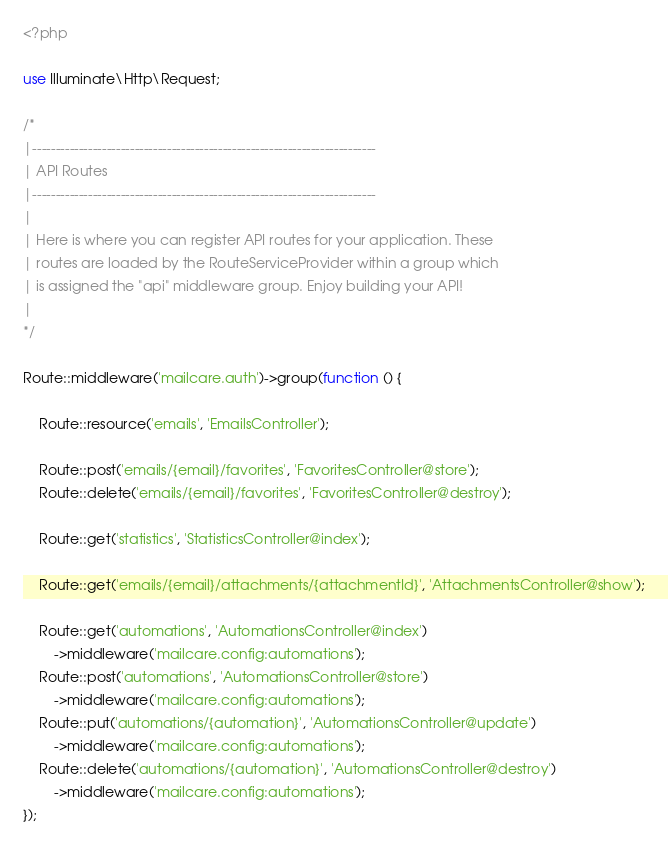Convert code to text. <code><loc_0><loc_0><loc_500><loc_500><_PHP_><?php

use Illuminate\Http\Request;

/*
|--------------------------------------------------------------------------
| API Routes
|--------------------------------------------------------------------------
|
| Here is where you can register API routes for your application. These
| routes are loaded by the RouteServiceProvider within a group which
| is assigned the "api" middleware group. Enjoy building your API!
|
*/

Route::middleware('mailcare.auth')->group(function () {

    Route::resource('emails', 'EmailsController');

    Route::post('emails/{email}/favorites', 'FavoritesController@store');
    Route::delete('emails/{email}/favorites', 'FavoritesController@destroy');

    Route::get('statistics', 'StatisticsController@index');

    Route::get('emails/{email}/attachments/{attachmentId}', 'AttachmentsController@show');

    Route::get('automations', 'AutomationsController@index')
        ->middleware('mailcare.config:automations');
    Route::post('automations', 'AutomationsController@store')
        ->middleware('mailcare.config:automations');
    Route::put('automations/{automation}', 'AutomationsController@update')
        ->middleware('mailcare.config:automations');
    Route::delete('automations/{automation}', 'AutomationsController@destroy')
        ->middleware('mailcare.config:automations');
});
</code> 